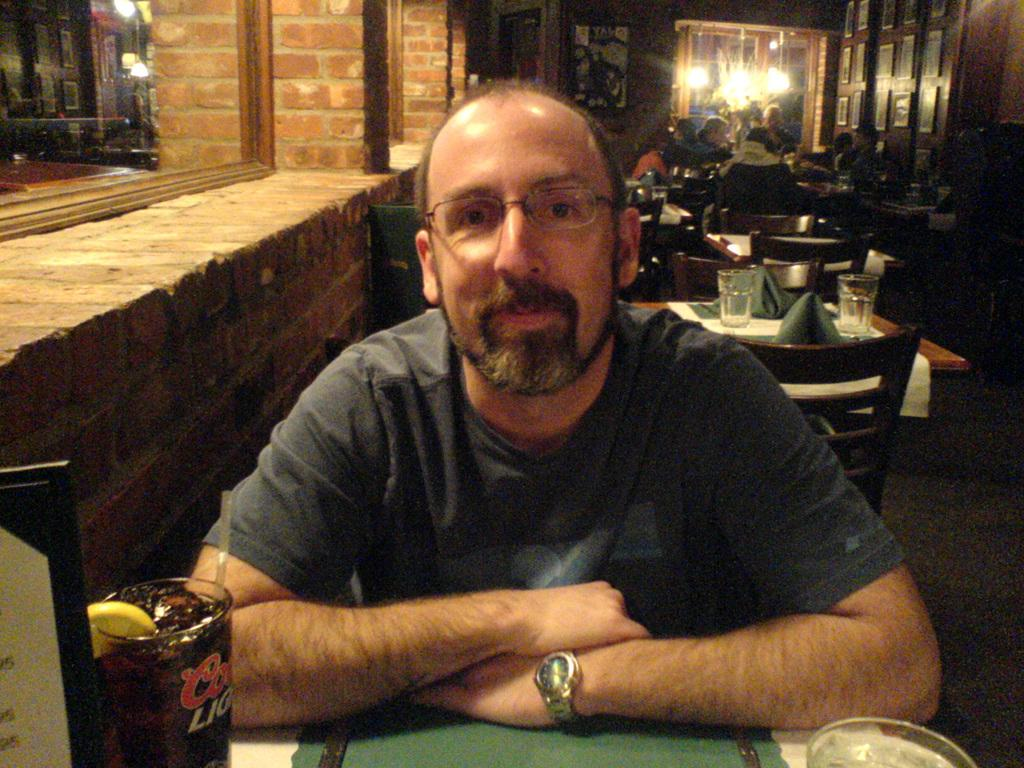What is the main subject of the image? There is a man in the image. What can be observed about the man's appearance? The man is wearing spectacles. What is the man's position in the image? The man is sitting on a chair. What is present in front of the chair? There is a table in front of the chair. What can be seen on the table? There is a glass on the table. What can be seen in the background of the image? There are other tables and chairs visible in the background. What type of poison is the man using to bite his nails in the image? There is no indication in the image that the man is using poison or biting his nails. 